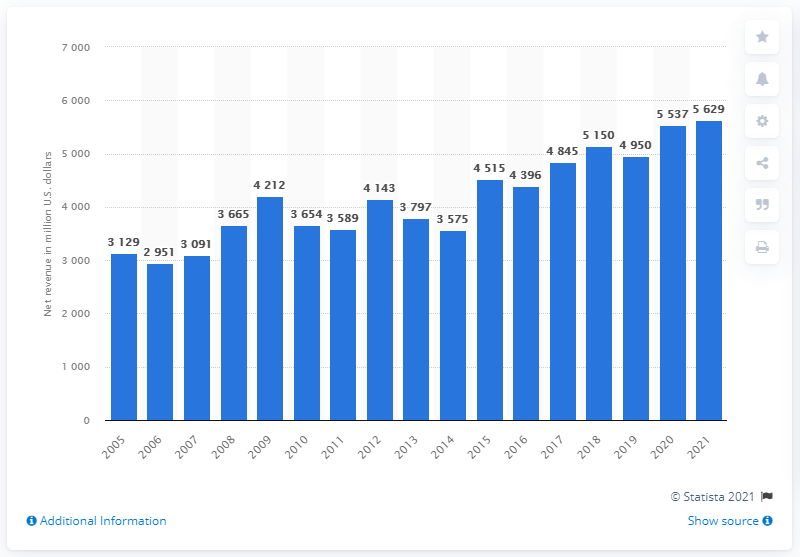Indicate a few pertinent items in this graphic. Electronic Arts' net revenue in the 2021 fiscal year was $56.29 billion. In 2016, the revenue of Electronic Arts was 4,396. 